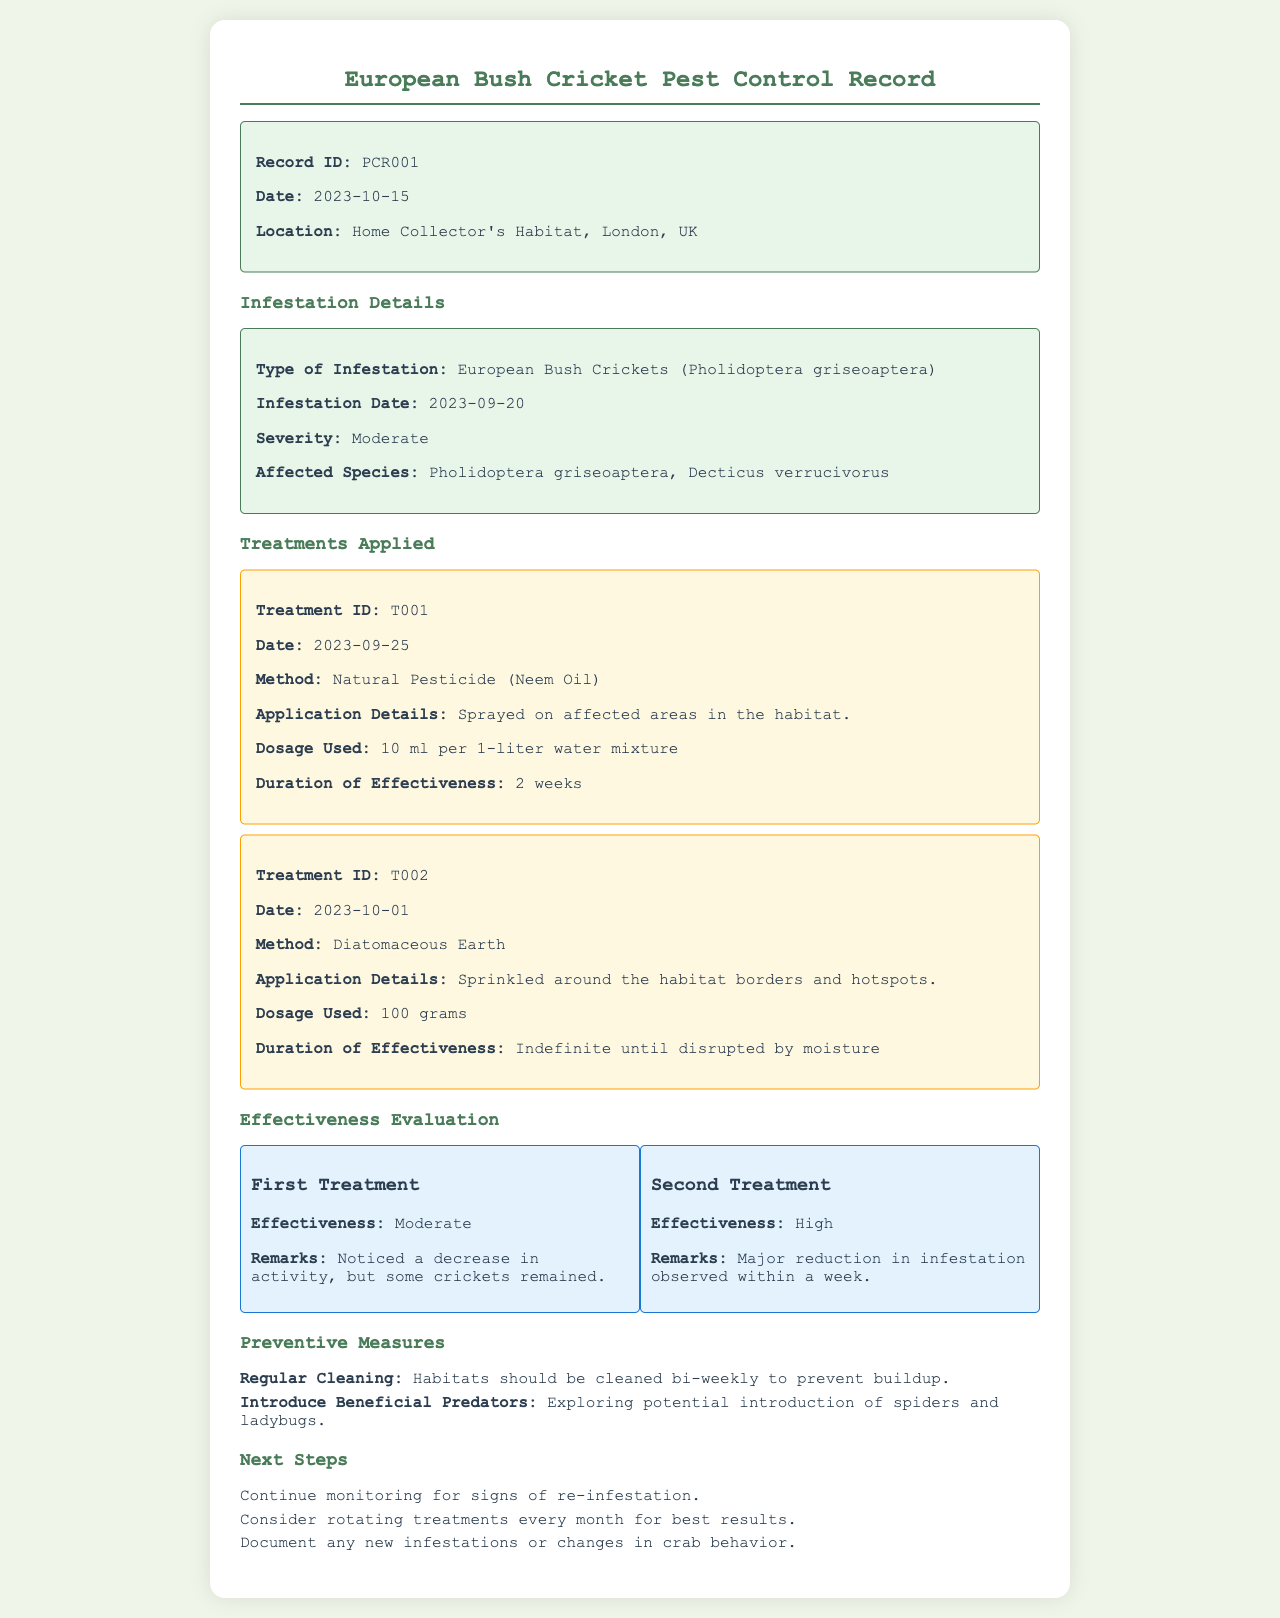What is the record ID? The record ID is stated clearly at the top of the document.
Answer: PCR001 What type of infestation occurred? The document specifies the type of infestation under the Infestation Details section.
Answer: European Bush Crickets (Pholidoptera griseoaptera) When was the second treatment applied? The date of the second treatment is mentioned in the Treatments Applied section.
Answer: 2023-10-01 What was the effectiveness of the first treatment? The effectiveness of the first treatment is detailed in the Effectiveness Evaluation section.
Answer: Moderate What dosage was used for the first treatment? The dosage details for the first treatment can be found under Treatments Applied.
Answer: 10 ml per 1-liter water mixture What preventive measures are mentioned? The document lists specific preventive measures in their respective section.
Answer: Regular Cleaning, Introduce Beneficial Predators How long is the duration of effectiveness for the second treatment? The duration for the second treatment is noted in the Treatments Applied section.
Answer: Indefinite until disrupted by moisture What was the severity of the infestation? The severity level of the infestation is stated in the Infestation Details section.
Answer: Moderate What next step involves monitoring? The next steps section outlines plans that specifically involve monitoring for signs of re-infestation.
Answer: Continue monitoring for signs of re-infestation 